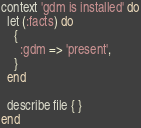<code> <loc_0><loc_0><loc_500><loc_500><_Ruby_>context 'gdm is installed' do
  let (:facts) do
    {        
      :gdm => 'present',
    }
  end

  describe file { }
end</code> 